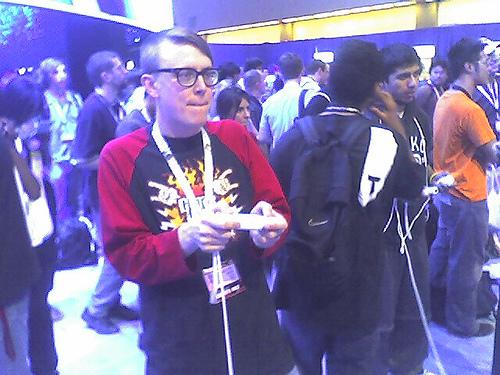What color are the sleeves on the first shirt?
Quick response, please. Red. What is he holding?
Quick response, please. Controller. Is this indoors?
Keep it brief. Yes. 